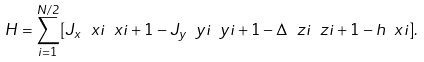<formula> <loc_0><loc_0><loc_500><loc_500>H = \sum _ { i = 1 } ^ { N / 2 } [ J _ { x } \ x { i } \ x { i + 1 } - J _ { y } \ y { i } \ y { i + 1 } - \Delta \ z { i } \ z { i + 1 } - h \ x { i } ] .</formula> 